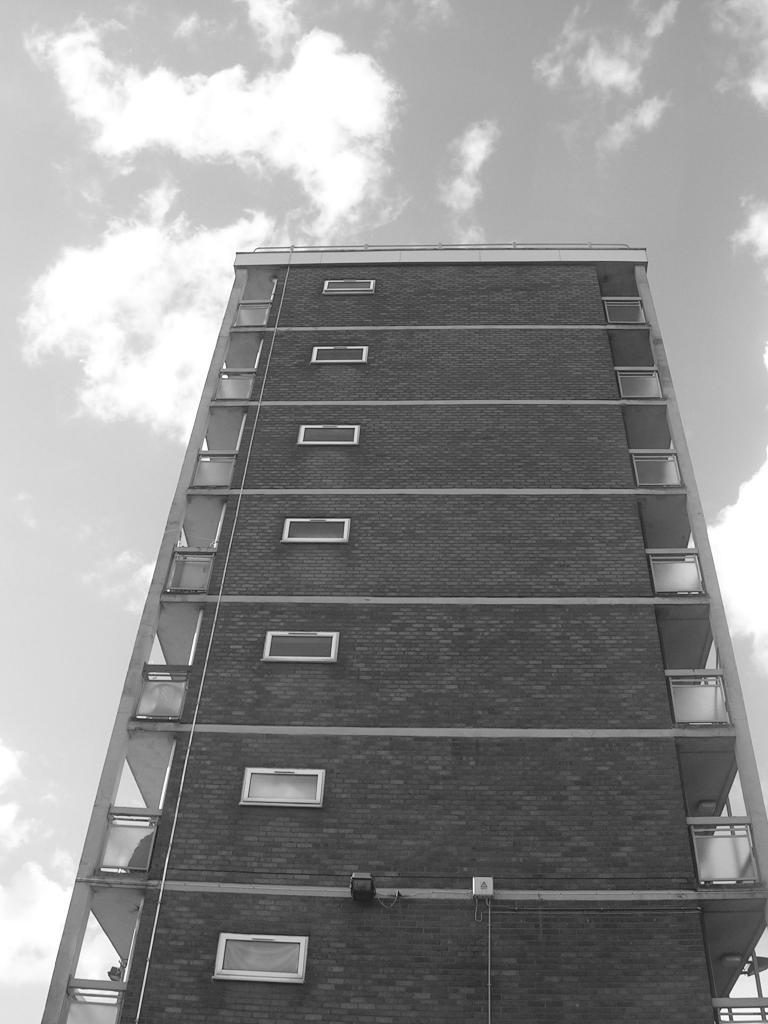What type of structure is depicted in the image? There is a building with many windows in the image. What can be seen in the background of the image? The sky is visible at the top of the image. How is the image presented in terms of color? The image is black and white. What type of transport can be seen in the image? There is no transport visible in the image; it only features a building and the sky. Is there a club present in the image? There is no mention of a club in the image; it only features a building and the sky. 